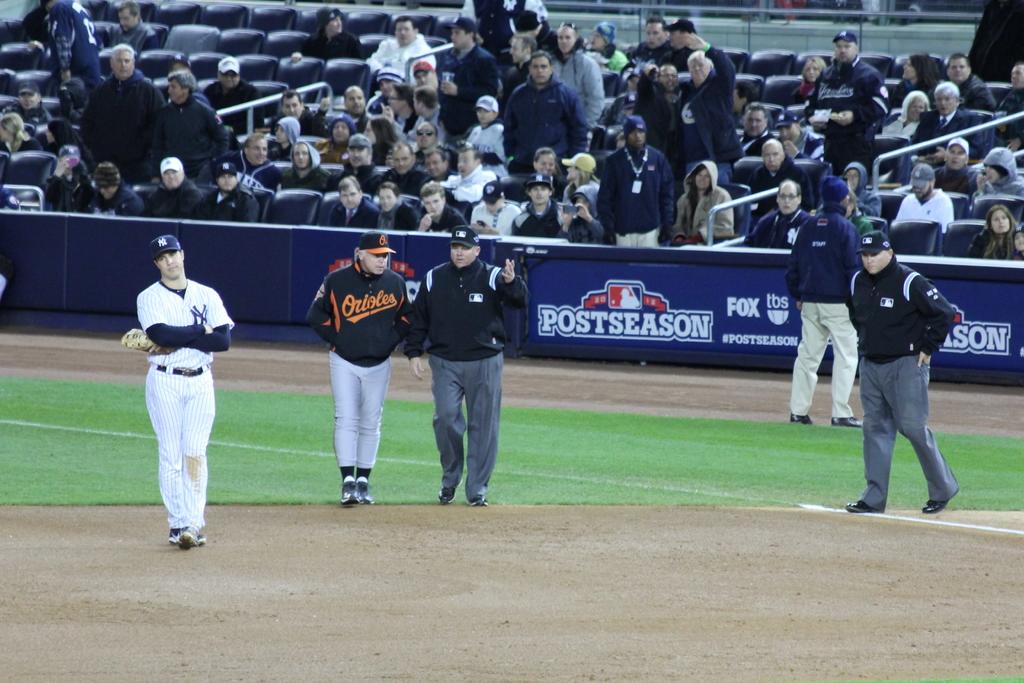What is the team name on the front of the uniform of the coach?
Your answer should be compact. Orioles. 